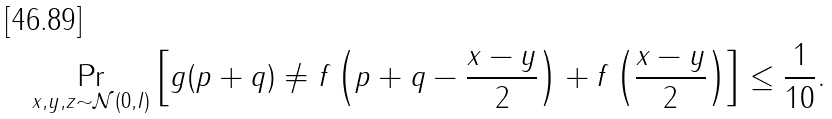<formula> <loc_0><loc_0><loc_500><loc_500>\Pr _ { x , y , z \sim \mathcal { N } ( 0 , I ) } \left [ g ( p + q ) \neq f \left ( p + q - \frac { x - y } { 2 } \right ) + f \left ( \frac { x - y } { 2 } \right ) \right ] \leq \frac { 1 } { 1 0 } .</formula> 